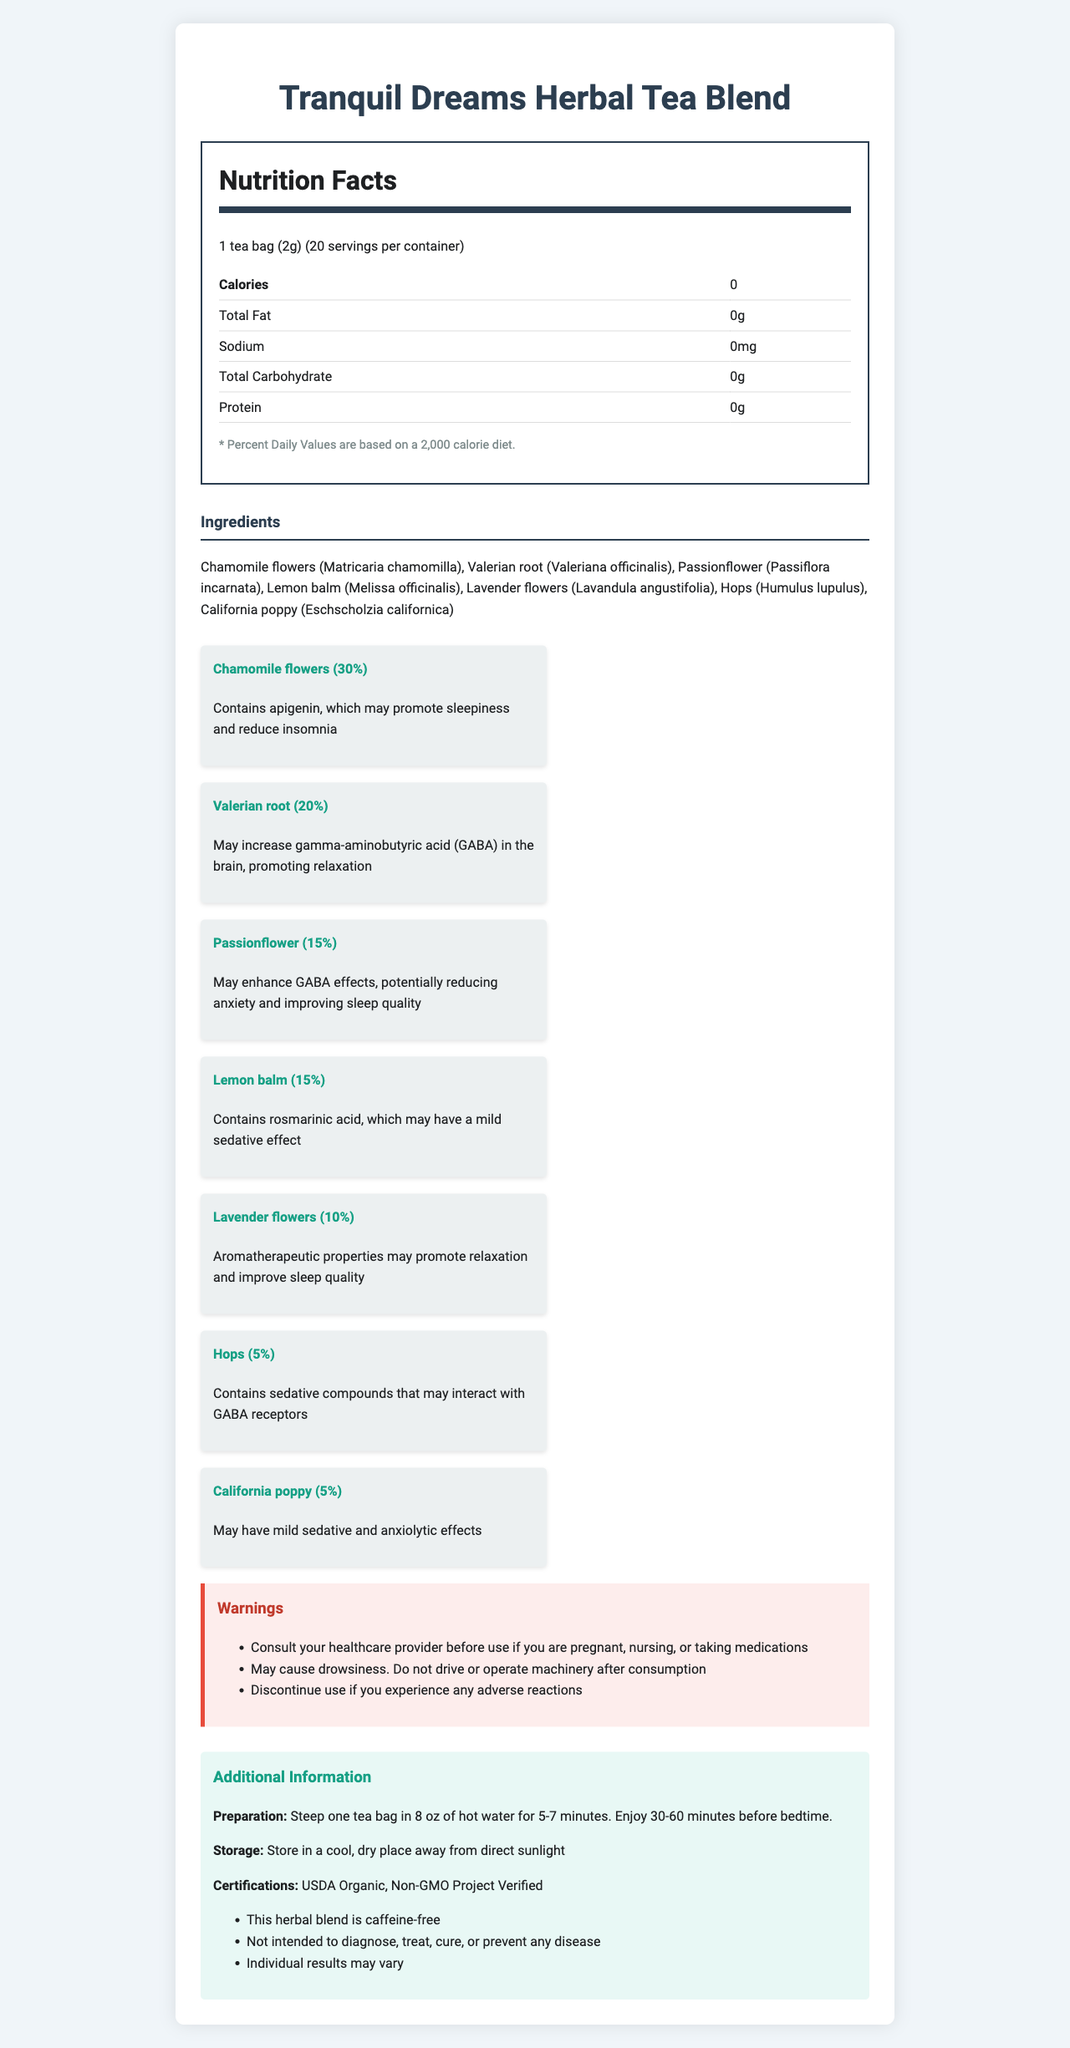what is the serving size? The serving size is listed as "1 tea bag (2g)" in the document.
Answer: 1 tea bag (2g) how many servings are there in one container? The document specifies "20 servings per container."
Answer: 20 servings are there any calories in each serving of the tea? The document states that the calories per serving is 0.
Answer: 0 calories which ingredient has the highest percentage in the herb blend? Chamomile flowers are listed with the highest percentage at 30%.
Answer: Chamomile flowers (30%) what are the benefits of Valerian root? The document states that Valerian root may increase GABA in the brain, which promotes relaxation.
Answer: May increase gamma-aminobutyric acid (GABA) in the brain, promoting relaxation What certification does this herbal tea blend possess? The certifications listed are USDA Organic and Non-GMO Project Verified.
Answer: USDA Organic, Non-GMO Project Verified Which ingredient is known for its aromatherapeutic properties? A. Chamomile flowers B. Valerian root C. Lavender flowers D. California poppy Lavender flowers are noted for their aromatherapeutic properties which may promote relaxation and improve sleep quality.
Answer: C. Lavender flowers How should the tea be prepared? A. Steep one tea bag in 8 oz of hot water for 2 minutes B. Boil for 10 minutes C. Steep one tea bag in 8 oz of hot water for 5-7 minutes D. Add one tea bag to cold water overnight The preparation instructions specify to steep one tea bag in 8 oz of hot water for 5-7 minutes.
Answer: C. Steep one tea bag in 8 oz of hot water for 5-7 minutes Should you drive after consuming this tea? The document includes a warning that consuming the tea may cause drowsiness and advises not to drive or operate machinery.
Answer: No What is the main idea of this document? This document aims to inform potential consumers about the Tranquil Dreams Herbal Tea Blend, focusing on its composition, health benefits, and usage instructions.
Answer: The document provides detailed information about the Tranquil Dreams Herbal Tea Blend, including its nutritional facts, ingredients, benefits, warnings, preparation, storage instructions, certifications, and additional information. Does the herbal tea blend contain sugar? The document does not explicitly state whether there is sugar in the blend, but it lists total carbohydrates as 0g, making it unclear without further details.
Answer: Cannot be determined 